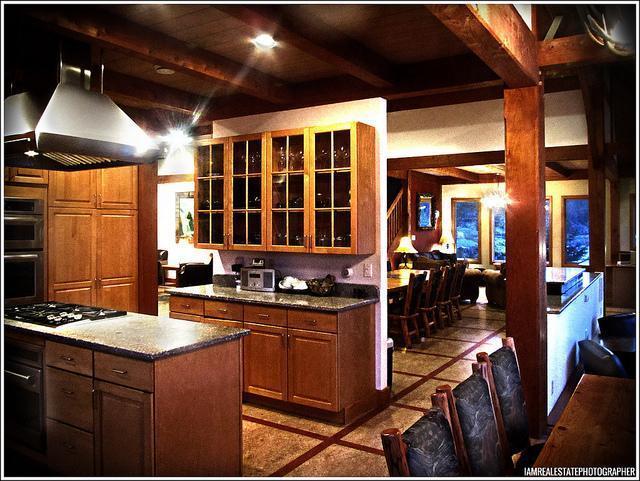How many ovens are there?
Give a very brief answer. 1. How many chairs are there?
Give a very brief answer. 3. 